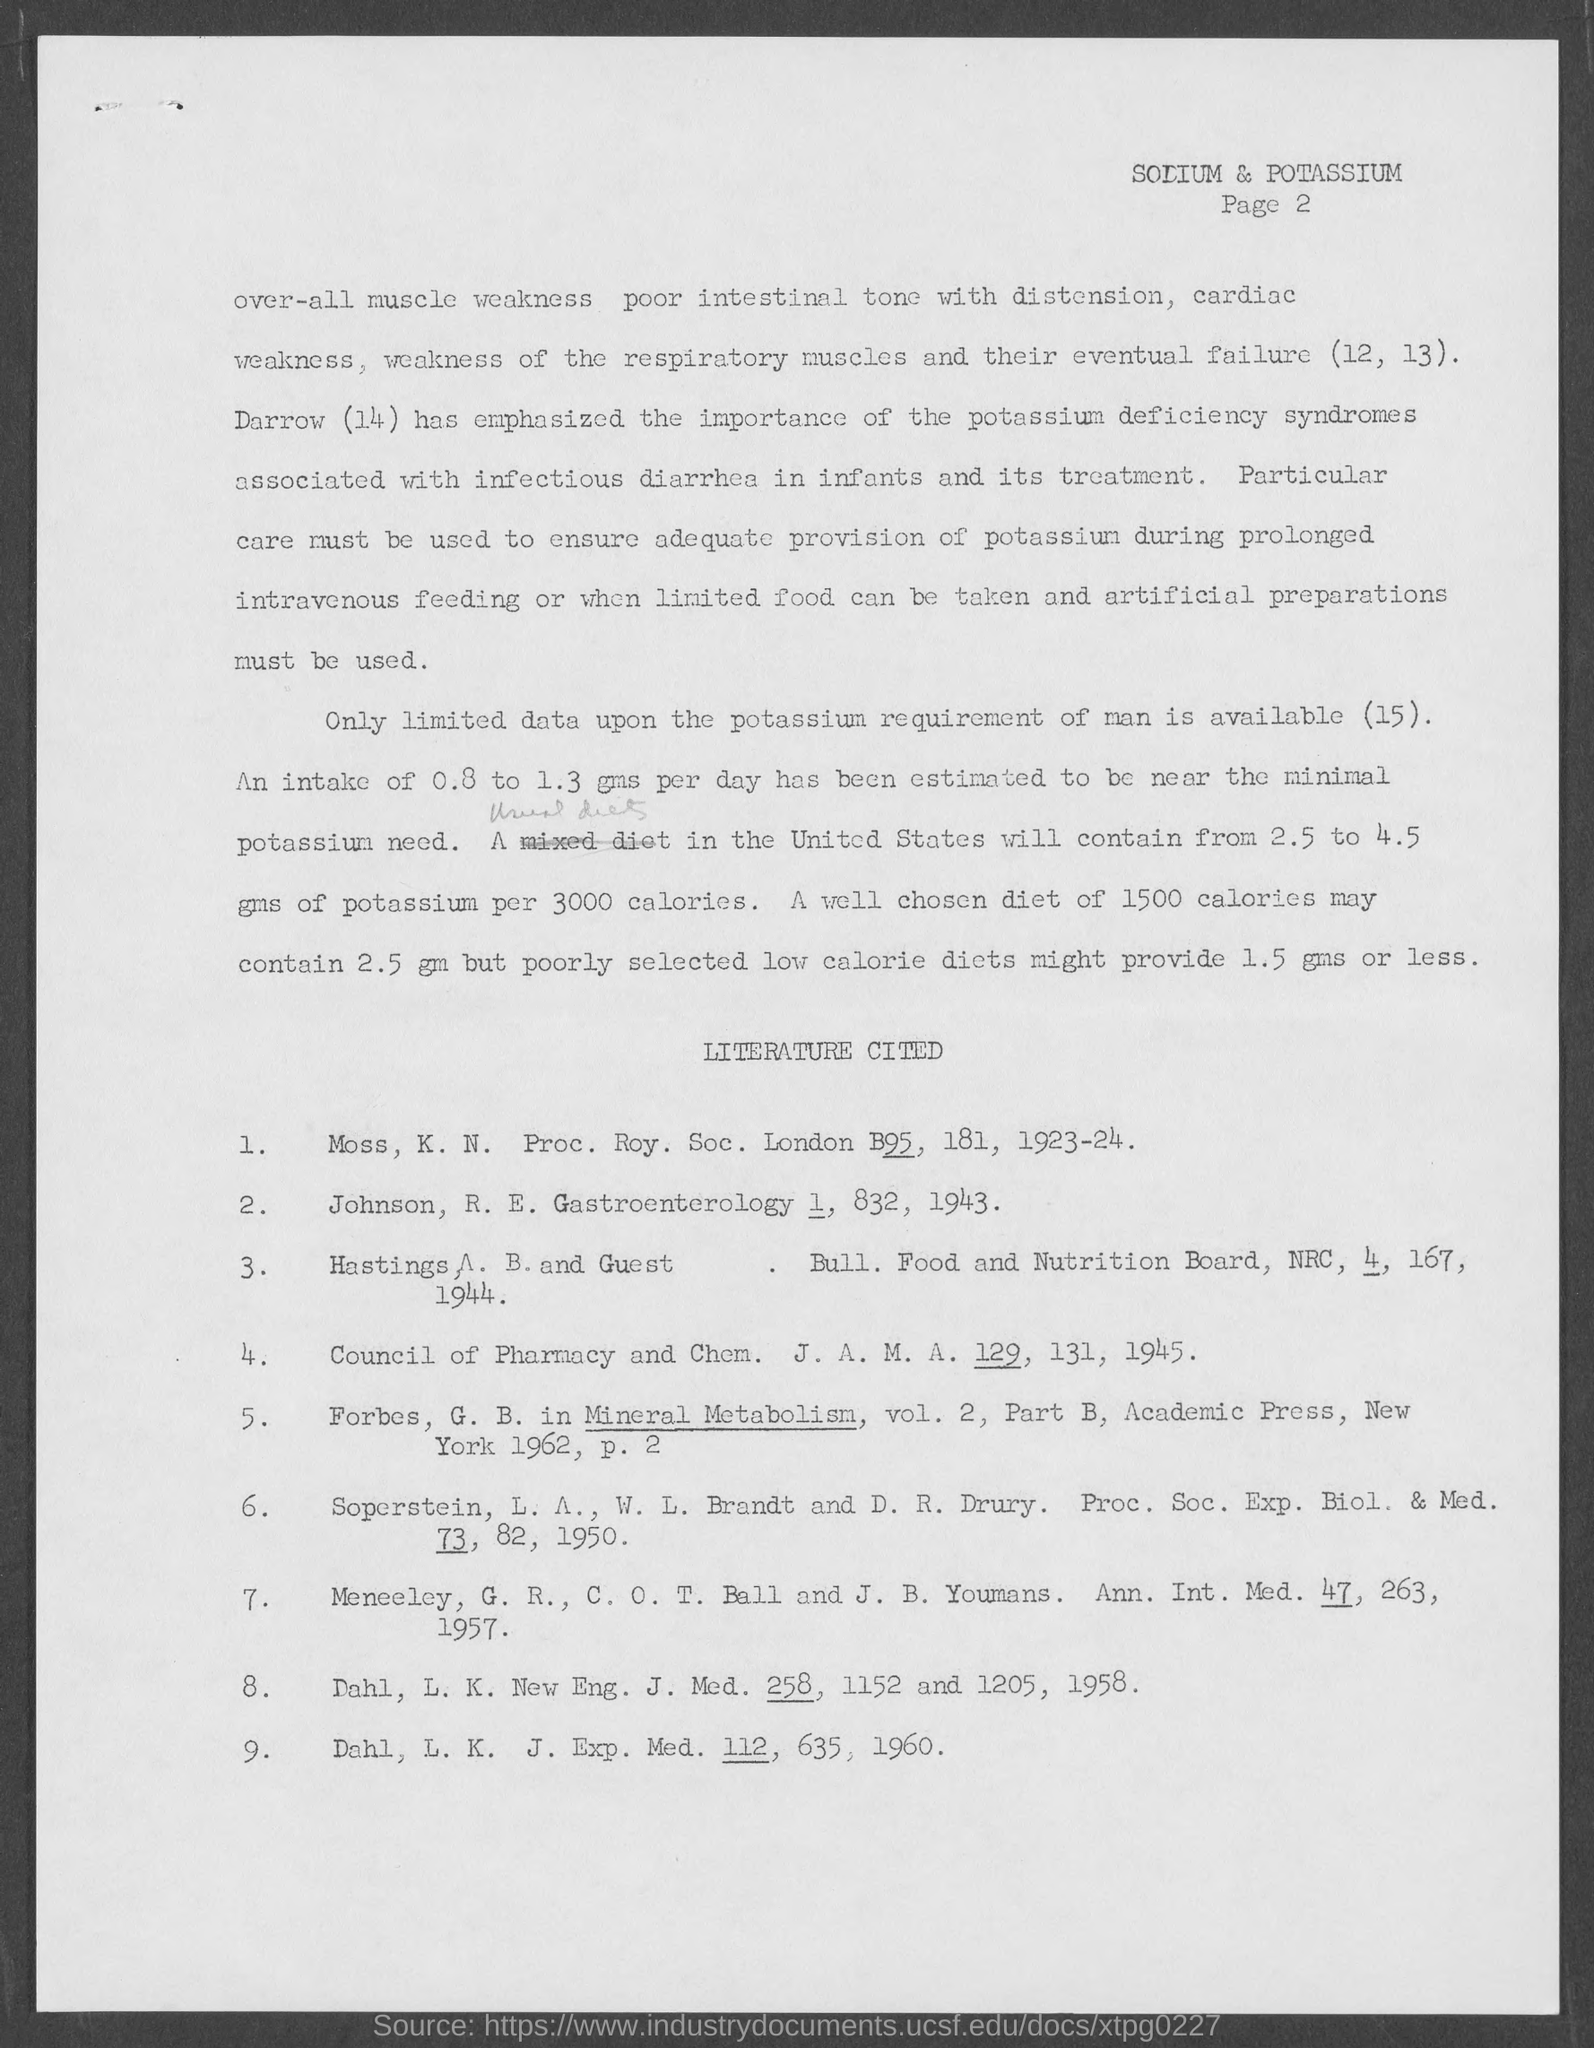What is the page number?
Offer a terse response. Page 2. 